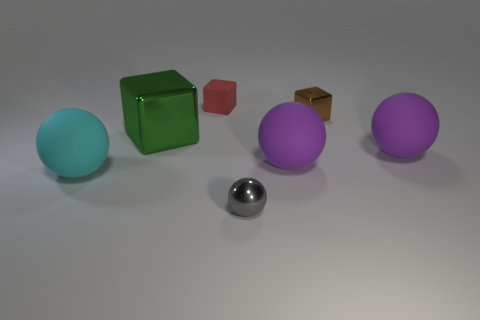What color is the big shiny object?
Keep it short and to the point. Green. There is a shiny cube on the left side of the red cube; how big is it?
Your answer should be very brief. Large. What number of large things have the same color as the rubber block?
Your answer should be very brief. 0. Is there a big rubber sphere that is in front of the sphere that is left of the large cube?
Your answer should be very brief. No. There is a cube on the right side of the gray thing; is its color the same as the ball on the left side of the small gray sphere?
Offer a terse response. No. What color is the other cube that is the same size as the red rubber cube?
Make the answer very short. Brown. Is the number of green blocks on the right side of the small gray metallic sphere the same as the number of large cubes that are on the left side of the cyan matte object?
Your response must be concise. Yes. The small thing that is in front of the matte object left of the small red cube is made of what material?
Offer a terse response. Metal. How many objects are tiny gray balls or purple rubber spheres?
Your answer should be compact. 3. Is the number of small yellow rubber cubes less than the number of cyan spheres?
Offer a terse response. Yes. 